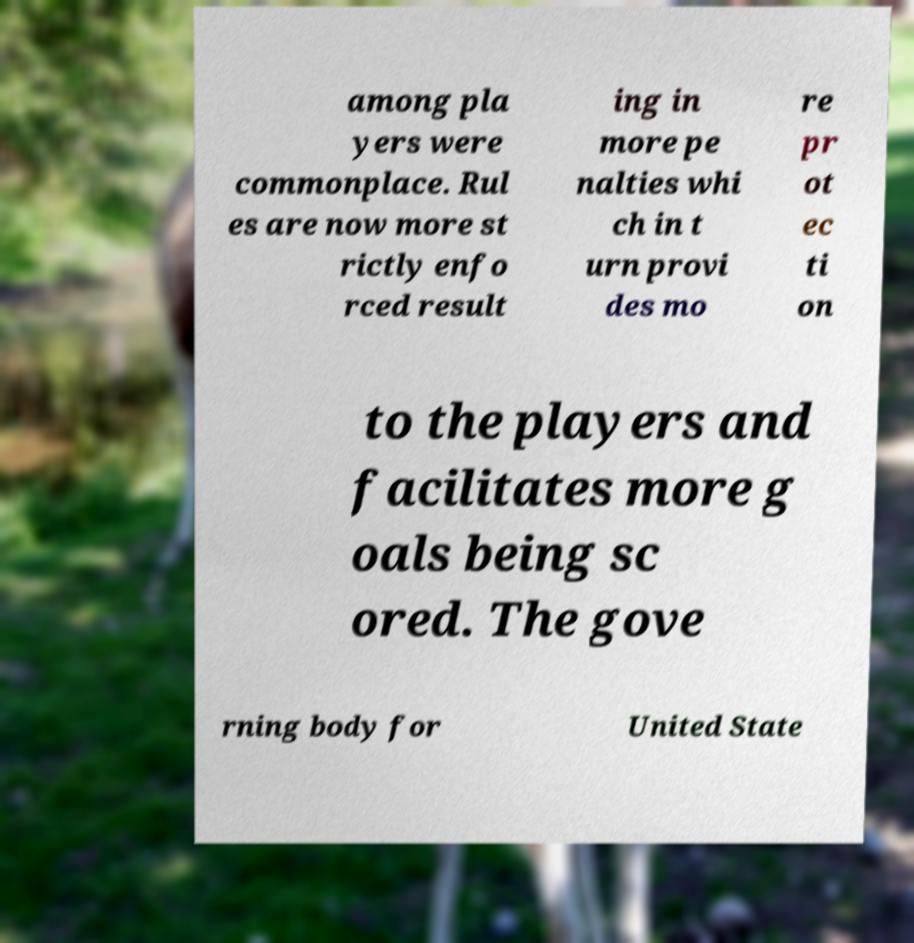Could you extract and type out the text from this image? among pla yers were commonplace. Rul es are now more st rictly enfo rced result ing in more pe nalties whi ch in t urn provi des mo re pr ot ec ti on to the players and facilitates more g oals being sc ored. The gove rning body for United State 